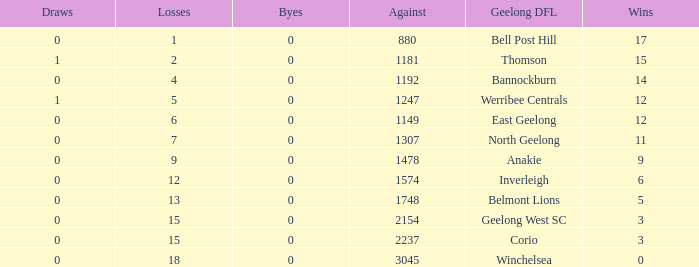What is the lowest number of wins where the losses are more than 12 and the draws are less than 0? None. 